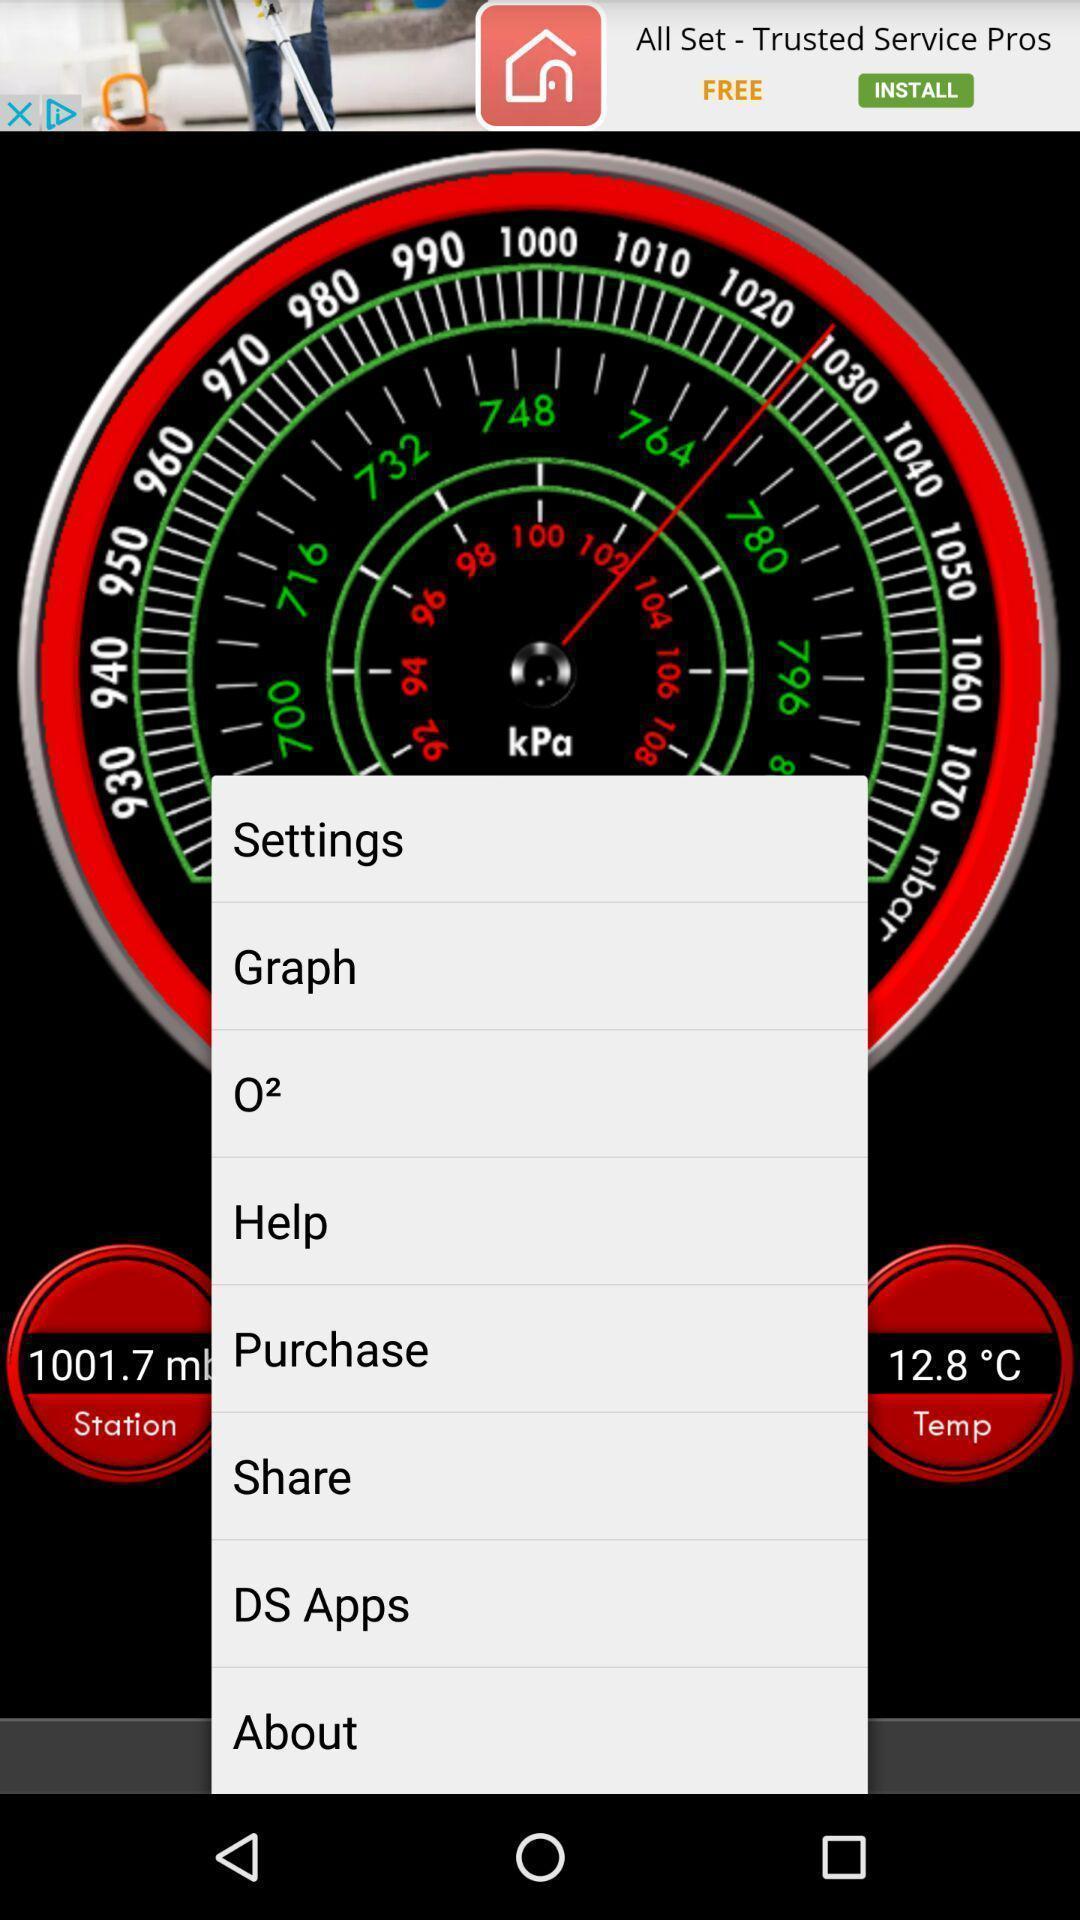Tell me what you see in this picture. Screen displaying various features. 